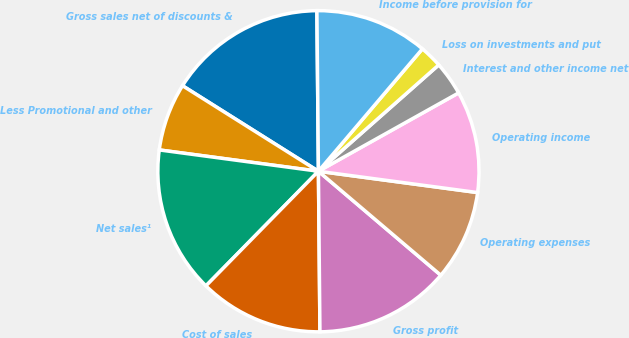Convert chart. <chart><loc_0><loc_0><loc_500><loc_500><pie_chart><fcel>Gross sales net of discounts &<fcel>Less Promotional and other<fcel>Net sales¹<fcel>Cost of sales<fcel>Gross profit<fcel>Operating expenses<fcel>Operating income<fcel>Interest and other income net<fcel>Loss on investments and put<fcel>Income before provision for<nl><fcel>15.91%<fcel>6.82%<fcel>14.77%<fcel>12.5%<fcel>13.64%<fcel>9.09%<fcel>10.23%<fcel>3.41%<fcel>2.27%<fcel>11.36%<nl></chart> 